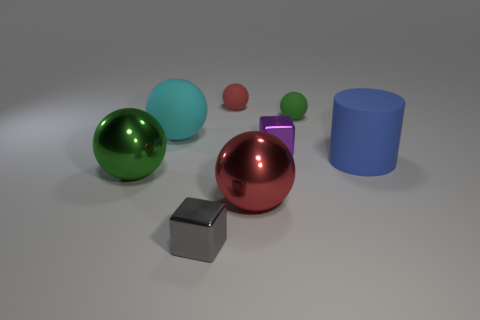Subtract all large cyan matte spheres. How many spheres are left? 4 Subtract all cyan balls. How many balls are left? 4 Subtract all yellow spheres. Subtract all red cylinders. How many spheres are left? 5 Add 1 blue objects. How many objects exist? 9 Subtract all cubes. How many objects are left? 6 Add 8 tiny purple metal blocks. How many tiny purple metal blocks are left? 9 Add 2 small blue objects. How many small blue objects exist? 2 Subtract 0 yellow blocks. How many objects are left? 8 Subtract all red matte balls. Subtract all small gray metal blocks. How many objects are left? 6 